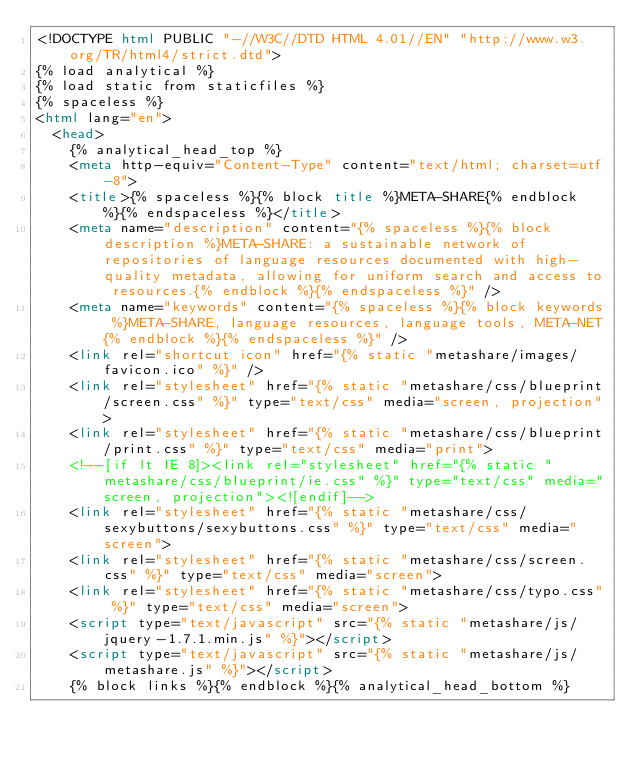Convert code to text. <code><loc_0><loc_0><loc_500><loc_500><_HTML_><!DOCTYPE html PUBLIC "-//W3C//DTD HTML 4.01//EN" "http://www.w3.org/TR/html4/strict.dtd">
{% load analytical %}
{% load static from staticfiles %}
{% spaceless %}
<html lang="en">
  <head>
    {% analytical_head_top %}
    <meta http-equiv="Content-Type" content="text/html; charset=utf-8">
    <title>{% spaceless %}{% block title %}META-SHARE{% endblock %}{% endspaceless %}</title>
    <meta name="description" content="{% spaceless %}{% block description %}META-SHARE: a sustainable network of repositories of language resources documented with high-quality metadata, allowing for uniform search and access to resources.{% endblock %}{% endspaceless %}" />
    <meta name="keywords" content="{% spaceless %}{% block keywords %}META-SHARE, language resources, language tools, META-NET{% endblock %}{% endspaceless %}" />
    <link rel="shortcut icon" href="{% static "metashare/images/favicon.ico" %}" />
    <link rel="stylesheet" href="{% static "metashare/css/blueprint/screen.css" %}" type="text/css" media="screen, projection">
    <link rel="stylesheet" href="{% static "metashare/css/blueprint/print.css" %}" type="text/css" media="print">
    <!--[if lt IE 8]><link rel="stylesheet" href="{% static "metashare/css/blueprint/ie.css" %}" type="text/css" media="screen, projection"><![endif]-->
    <link rel="stylesheet" href="{% static "metashare/css/sexybuttons/sexybuttons.css" %}" type="text/css" media="screen">
    <link rel="stylesheet" href="{% static "metashare/css/screen.css" %}" type="text/css" media="screen">
    <link rel="stylesheet" href="{% static "metashare/css/typo.css" %}" type="text/css" media="screen">
    <script type="text/javascript" src="{% static "metashare/js/jquery-1.7.1.min.js" %}"></script>
    <script type="text/javascript" src="{% static "metashare/js/metashare.js" %}"></script>
    {% block links %}{% endblock %}{% analytical_head_bottom %}</code> 